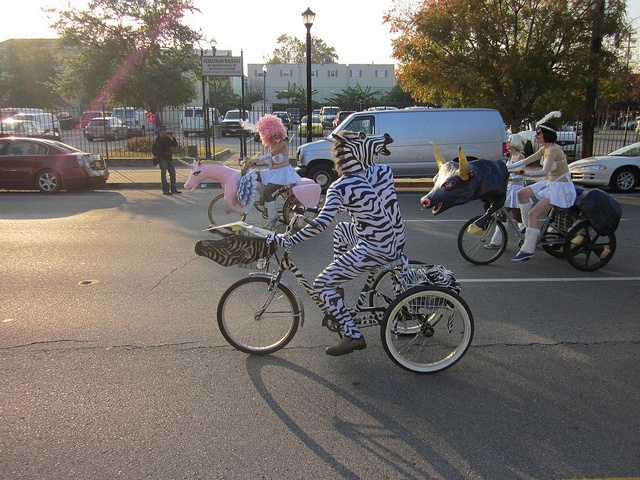Describe the objects in this image and their specific colors. I can see bicycle in white, gray, and black tones, people in white, black, and gray tones, truck in white, gray, and black tones, bicycle in white, black, gray, and darkgray tones, and car in white, gray, black, and maroon tones in this image. 